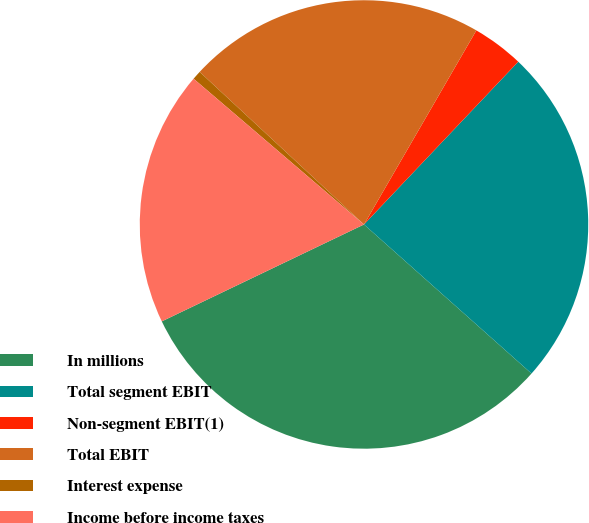Convert chart to OTSL. <chart><loc_0><loc_0><loc_500><loc_500><pie_chart><fcel>In millions<fcel>Total segment EBIT<fcel>Non-segment EBIT(1)<fcel>Total EBIT<fcel>Interest expense<fcel>Income before income taxes<nl><fcel>31.31%<fcel>24.5%<fcel>3.72%<fcel>21.44%<fcel>0.65%<fcel>18.37%<nl></chart> 